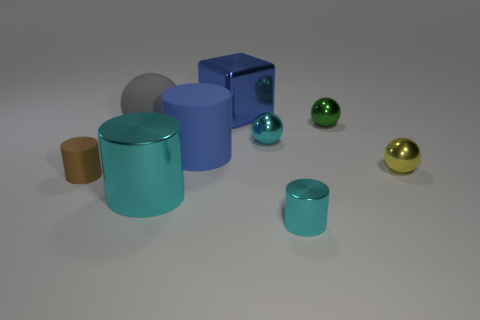Subtract 1 cylinders. How many cylinders are left? 3 Add 1 yellow balls. How many objects exist? 10 Subtract all spheres. How many objects are left? 5 Add 3 large blue matte cylinders. How many large blue matte cylinders exist? 4 Subtract 0 blue spheres. How many objects are left? 9 Subtract all blue rubber objects. Subtract all small matte cylinders. How many objects are left? 7 Add 4 big shiny cubes. How many big shiny cubes are left? 5 